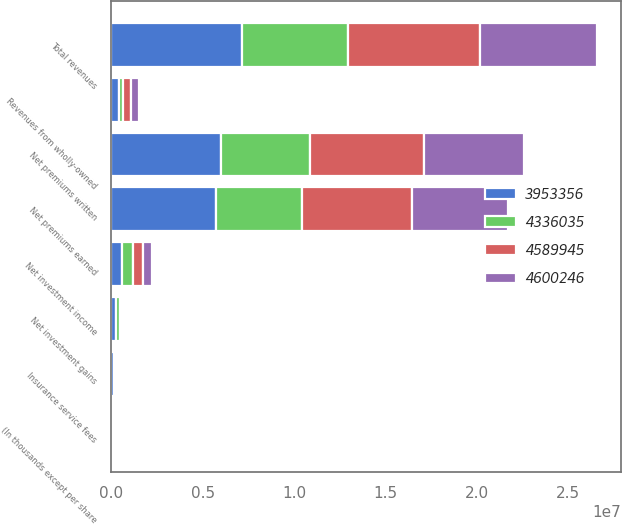Convert chart to OTSL. <chart><loc_0><loc_0><loc_500><loc_500><stacked_bar_chart><ecel><fcel>(In thousands except per share<fcel>Net premiums written<fcel>Net premiums earned<fcel>Net investment income<fcel>Insurance service fees<fcel>Net investment gains<fcel>Revenues from wholly-owned<fcel>Total revenues<nl><fcel>4.58994e+06<fcel>2015<fcel>6.18952e+06<fcel>6.04061e+06<fcel>512645<fcel>139440<fcel>92324<fcel>421102<fcel>7.20646e+06<nl><fcel>3.95336e+06<fcel>2014<fcel>5.99695e+06<fcel>5.74442e+06<fcel>600885<fcel>117443<fcel>254852<fcel>410022<fcel>7.12893e+06<nl><fcel>4.60025e+06<fcel>2013<fcel>5.50017e+06<fcel>5.22654e+06<fcel>544291<fcel>107513<fcel>121544<fcel>407623<fcel>6.40853e+06<nl><fcel>4.33604e+06<fcel>2012<fcel>4.89854e+06<fcel>4.67352e+06<fcel>586763<fcel>103133<fcel>210465<fcel>247113<fcel>5.82355e+06<nl></chart> 